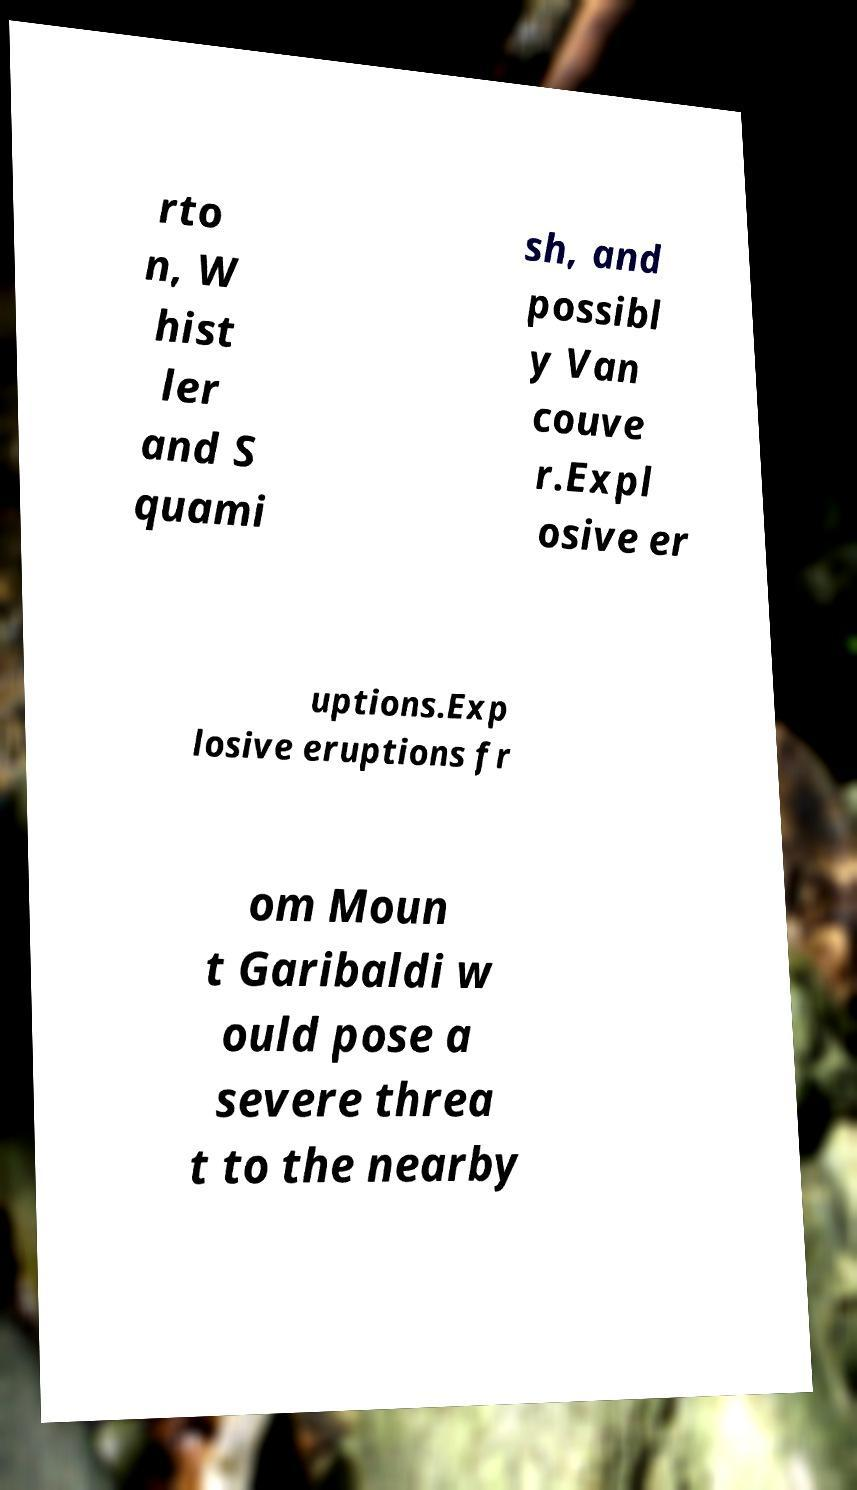Can you read and provide the text displayed in the image?This photo seems to have some interesting text. Can you extract and type it out for me? rto n, W hist ler and S quami sh, and possibl y Van couve r.Expl osive er uptions.Exp losive eruptions fr om Moun t Garibaldi w ould pose a severe threa t to the nearby 